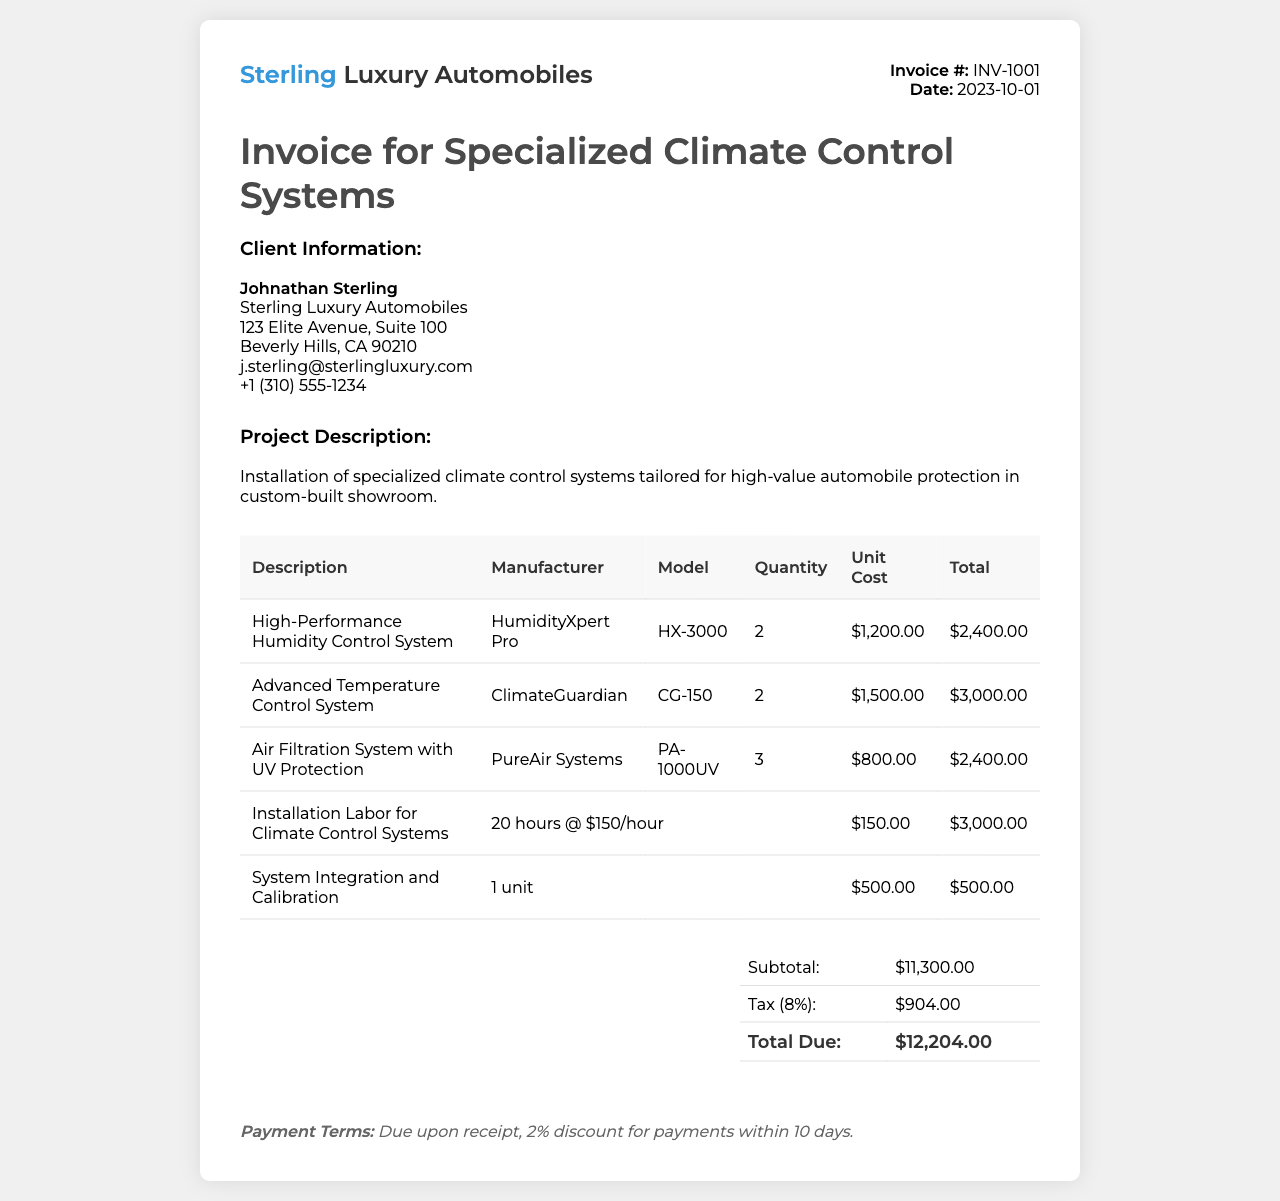What is the invoice number? The invoice number is specified in the header section of the document.
Answer: INV-1001 Who is the client? The client's name is mentioned in the client information section.
Answer: Johnathan Sterling What is the date of the invoice? The date is provided in the invoice info section.
Answer: 2023-10-01 How many units of the High-Performance Humidity Control System were ordered? The quantity ordered is specified in the table under the quantity column.
Answer: 2 What is the total cost for the Advanced Temperature Control System? The total cost for this item is found in the total column of the table.
Answer: $3,000.00 What is the subtotal amount? The subtotal amount is provided in the summary table at the bottom of the document.
Answer: $11,300.00 What percentage is the tax applied in the invoice? The tax percentage is mentioned next to the tax amount in the summary section.
Answer: 8% What is the payment term stated in the document? The payment terms are detailed at the bottom of the invoice.
Answer: Due upon receipt, 2% discount for payments within 10 days How many hours of installation labor were charged? The number of hours charged for installation labor is noted in the table.
Answer: 20 hours 